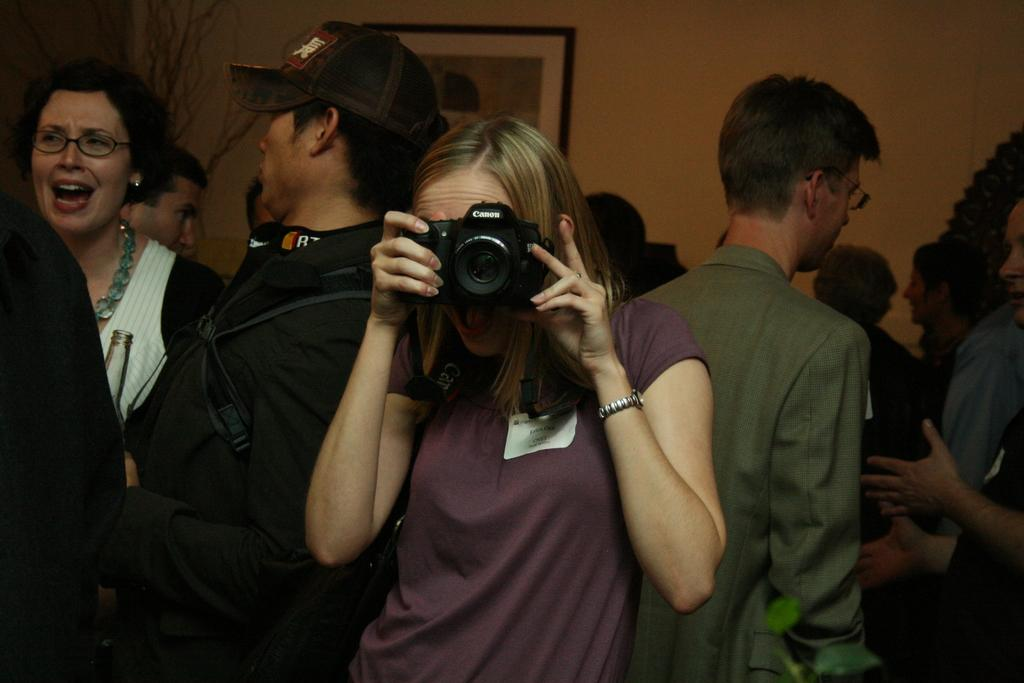How many people are present in the image? There are multiple people in the image. What are the people in the image doing? The people are standing. Can you describe the woman in the image? The woman is in the image, and she is holding a camera in her hand. Where is the clock located in the image? There is no clock present in the image. What type of cap is the woman wearing in the image? The woman is not wearing a cap in the image; she is holding a camera in her hand. 